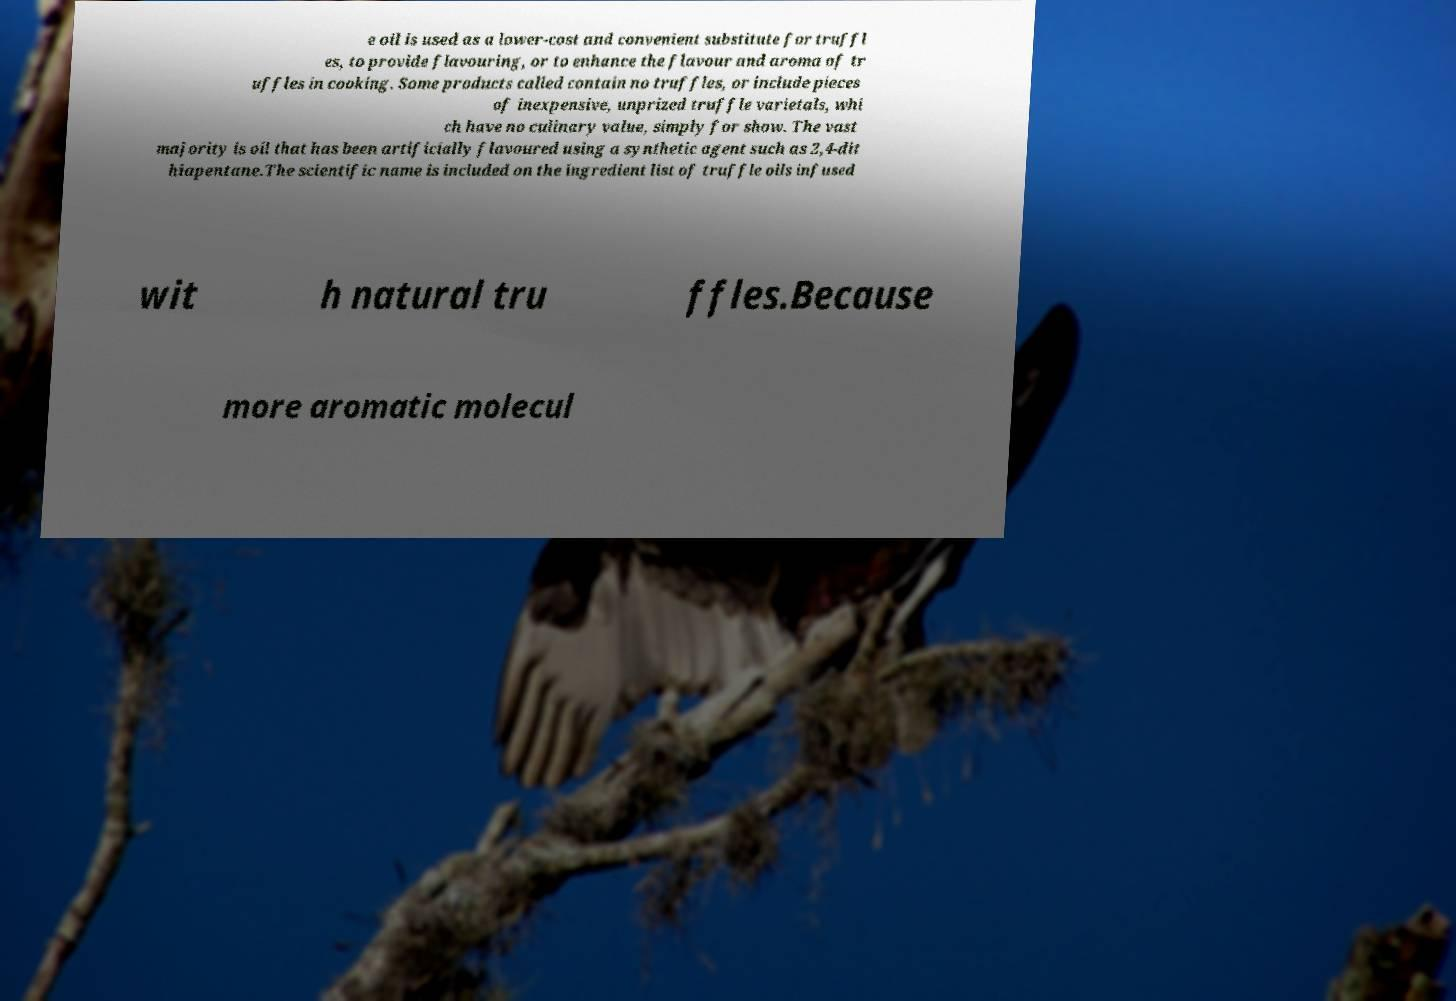I need the written content from this picture converted into text. Can you do that? e oil is used as a lower-cost and convenient substitute for truffl es, to provide flavouring, or to enhance the flavour and aroma of tr uffles in cooking. Some products called contain no truffles, or include pieces of inexpensive, unprized truffle varietals, whi ch have no culinary value, simply for show. The vast majority is oil that has been artificially flavoured using a synthetic agent such as 2,4-dit hiapentane.The scientific name is included on the ingredient list of truffle oils infused wit h natural tru ffles.Because more aromatic molecul 